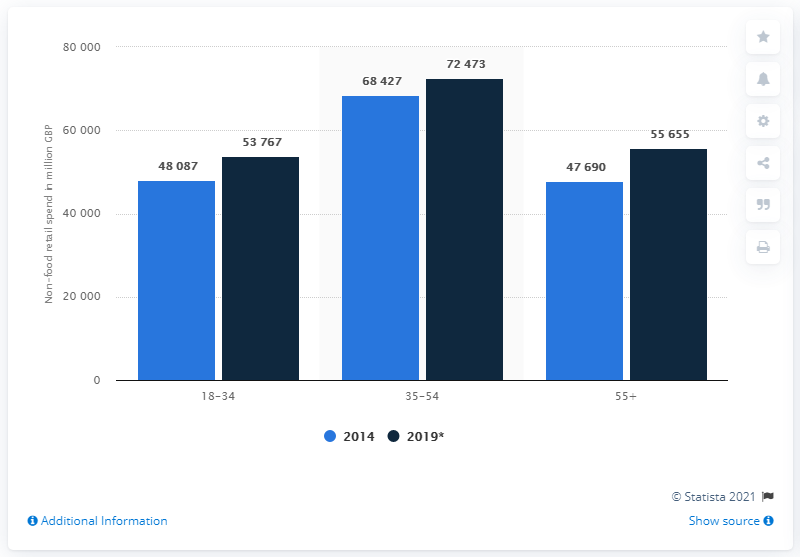Identify some key points in this picture. In 2014, 18 to 34 year olds in the UK spent an estimated 48,087 on non-food retail items. According to projections for 2019, the spending of 18 to 34 year olds is expected to be approximately 53,767. 